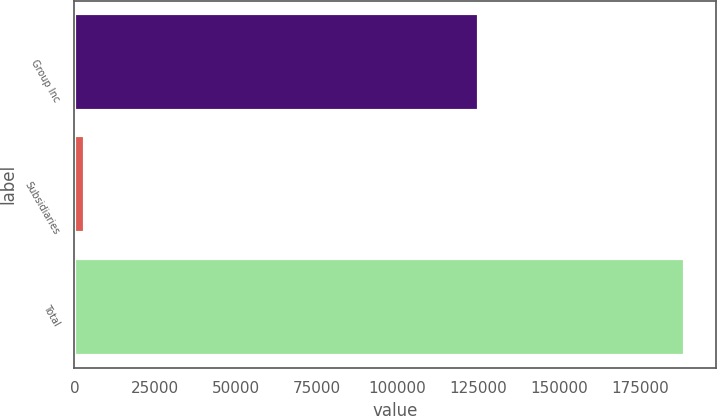Convert chart to OTSL. <chart><loc_0><loc_0><loc_500><loc_500><bar_chart><fcel>Group Inc<fcel>Subsidiaries<fcel>Total<nl><fcel>125159<fcel>3113<fcel>189086<nl></chart> 